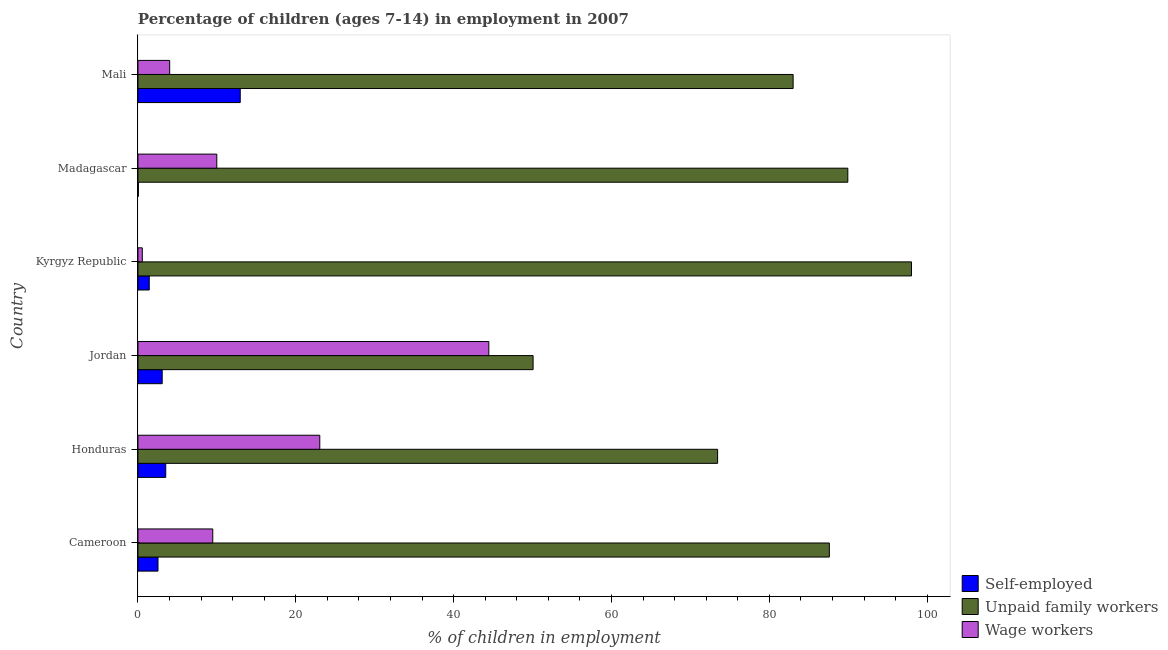How many different coloured bars are there?
Offer a terse response. 3. How many groups of bars are there?
Give a very brief answer. 6. Are the number of bars per tick equal to the number of legend labels?
Your answer should be compact. Yes. Are the number of bars on each tick of the Y-axis equal?
Keep it short and to the point. Yes. What is the label of the 4th group of bars from the top?
Provide a succinct answer. Jordan. What is the percentage of children employed as unpaid family workers in Cameroon?
Your answer should be very brief. 87.61. Across all countries, what is the maximum percentage of children employed as unpaid family workers?
Make the answer very short. 98.02. Across all countries, what is the minimum percentage of children employed as unpaid family workers?
Your answer should be compact. 50.07. In which country was the percentage of children employed as wage workers maximum?
Make the answer very short. Jordan. In which country was the percentage of self employed children minimum?
Give a very brief answer. Madagascar. What is the total percentage of self employed children in the graph?
Keep it short and to the point. 23.57. What is the difference between the percentage of children employed as wage workers in Jordan and that in Kyrgyz Republic?
Give a very brief answer. 43.91. What is the difference between the percentage of self employed children in Kyrgyz Republic and the percentage of children employed as unpaid family workers in Madagascar?
Make the answer very short. -88.52. What is the average percentage of self employed children per country?
Give a very brief answer. 3.93. What is the difference between the percentage of self employed children and percentage of children employed as wage workers in Mali?
Ensure brevity in your answer.  8.94. In how many countries, is the percentage of children employed as wage workers greater than 4 %?
Provide a succinct answer. 5. What is the ratio of the percentage of self employed children in Jordan to that in Madagascar?
Keep it short and to the point. 61.4. Is the percentage of children employed as wage workers in Jordan less than that in Kyrgyz Republic?
Make the answer very short. No. What is the difference between the highest and the second highest percentage of self employed children?
Offer a very short reply. 9.44. What is the difference between the highest and the lowest percentage of children employed as unpaid family workers?
Offer a terse response. 47.95. Is the sum of the percentage of self employed children in Kyrgyz Republic and Mali greater than the maximum percentage of children employed as unpaid family workers across all countries?
Make the answer very short. No. What does the 3rd bar from the top in Jordan represents?
Your answer should be compact. Self-employed. What does the 3rd bar from the bottom in Madagascar represents?
Give a very brief answer. Wage workers. Is it the case that in every country, the sum of the percentage of self employed children and percentage of children employed as unpaid family workers is greater than the percentage of children employed as wage workers?
Offer a very short reply. Yes. How many bars are there?
Make the answer very short. 18. Are all the bars in the graph horizontal?
Provide a short and direct response. Yes. How many countries are there in the graph?
Your response must be concise. 6. What is the difference between two consecutive major ticks on the X-axis?
Provide a succinct answer. 20. Are the values on the major ticks of X-axis written in scientific E-notation?
Give a very brief answer. No. Does the graph contain any zero values?
Your answer should be very brief. No. How many legend labels are there?
Keep it short and to the point. 3. How are the legend labels stacked?
Offer a very short reply. Vertical. What is the title of the graph?
Your answer should be very brief. Percentage of children (ages 7-14) in employment in 2007. Does "Maunufacturing" appear as one of the legend labels in the graph?
Give a very brief answer. No. What is the label or title of the X-axis?
Your answer should be compact. % of children in employment. What is the % of children in employment in Self-employed in Cameroon?
Your answer should be very brief. 2.54. What is the % of children in employment of Unpaid family workers in Cameroon?
Offer a very short reply. 87.61. What is the % of children in employment of Wage workers in Cameroon?
Provide a short and direct response. 9.48. What is the % of children in employment in Self-employed in Honduras?
Provide a short and direct response. 3.52. What is the % of children in employment of Unpaid family workers in Honduras?
Make the answer very short. 73.45. What is the % of children in employment of Wage workers in Honduras?
Provide a succinct answer. 23.04. What is the % of children in employment of Self-employed in Jordan?
Your answer should be compact. 3.07. What is the % of children in employment of Unpaid family workers in Jordan?
Provide a short and direct response. 50.07. What is the % of children in employment in Wage workers in Jordan?
Provide a succinct answer. 44.46. What is the % of children in employment in Self-employed in Kyrgyz Republic?
Your answer should be very brief. 1.43. What is the % of children in employment in Unpaid family workers in Kyrgyz Republic?
Ensure brevity in your answer.  98.02. What is the % of children in employment in Wage workers in Kyrgyz Republic?
Keep it short and to the point. 0.55. What is the % of children in employment of Unpaid family workers in Madagascar?
Make the answer very short. 89.95. What is the % of children in employment in Wage workers in Madagascar?
Offer a terse response. 9.99. What is the % of children in employment in Self-employed in Mali?
Give a very brief answer. 12.96. What is the % of children in employment in Unpaid family workers in Mali?
Provide a succinct answer. 83.02. What is the % of children in employment in Wage workers in Mali?
Ensure brevity in your answer.  4.02. Across all countries, what is the maximum % of children in employment of Self-employed?
Provide a short and direct response. 12.96. Across all countries, what is the maximum % of children in employment in Unpaid family workers?
Provide a short and direct response. 98.02. Across all countries, what is the maximum % of children in employment in Wage workers?
Provide a succinct answer. 44.46. Across all countries, what is the minimum % of children in employment in Unpaid family workers?
Offer a very short reply. 50.07. Across all countries, what is the minimum % of children in employment in Wage workers?
Give a very brief answer. 0.55. What is the total % of children in employment in Self-employed in the graph?
Your answer should be compact. 23.57. What is the total % of children in employment in Unpaid family workers in the graph?
Give a very brief answer. 482.12. What is the total % of children in employment in Wage workers in the graph?
Provide a short and direct response. 91.54. What is the difference between the % of children in employment in Self-employed in Cameroon and that in Honduras?
Your response must be concise. -0.98. What is the difference between the % of children in employment of Unpaid family workers in Cameroon and that in Honduras?
Give a very brief answer. 14.16. What is the difference between the % of children in employment of Wage workers in Cameroon and that in Honduras?
Your answer should be very brief. -13.56. What is the difference between the % of children in employment of Self-employed in Cameroon and that in Jordan?
Your response must be concise. -0.53. What is the difference between the % of children in employment of Unpaid family workers in Cameroon and that in Jordan?
Keep it short and to the point. 37.54. What is the difference between the % of children in employment in Wage workers in Cameroon and that in Jordan?
Offer a very short reply. -34.98. What is the difference between the % of children in employment of Self-employed in Cameroon and that in Kyrgyz Republic?
Make the answer very short. 1.11. What is the difference between the % of children in employment of Unpaid family workers in Cameroon and that in Kyrgyz Republic?
Provide a succinct answer. -10.41. What is the difference between the % of children in employment in Wage workers in Cameroon and that in Kyrgyz Republic?
Your response must be concise. 8.93. What is the difference between the % of children in employment in Self-employed in Cameroon and that in Madagascar?
Your response must be concise. 2.49. What is the difference between the % of children in employment in Unpaid family workers in Cameroon and that in Madagascar?
Offer a very short reply. -2.34. What is the difference between the % of children in employment of Wage workers in Cameroon and that in Madagascar?
Offer a terse response. -0.51. What is the difference between the % of children in employment of Self-employed in Cameroon and that in Mali?
Provide a short and direct response. -10.42. What is the difference between the % of children in employment in Unpaid family workers in Cameroon and that in Mali?
Keep it short and to the point. 4.59. What is the difference between the % of children in employment of Wage workers in Cameroon and that in Mali?
Offer a terse response. 5.46. What is the difference between the % of children in employment in Self-employed in Honduras and that in Jordan?
Ensure brevity in your answer.  0.45. What is the difference between the % of children in employment in Unpaid family workers in Honduras and that in Jordan?
Provide a short and direct response. 23.38. What is the difference between the % of children in employment of Wage workers in Honduras and that in Jordan?
Keep it short and to the point. -21.42. What is the difference between the % of children in employment in Self-employed in Honduras and that in Kyrgyz Republic?
Keep it short and to the point. 2.09. What is the difference between the % of children in employment of Unpaid family workers in Honduras and that in Kyrgyz Republic?
Your answer should be compact. -24.57. What is the difference between the % of children in employment in Wage workers in Honduras and that in Kyrgyz Republic?
Offer a terse response. 22.49. What is the difference between the % of children in employment of Self-employed in Honduras and that in Madagascar?
Your answer should be compact. 3.47. What is the difference between the % of children in employment of Unpaid family workers in Honduras and that in Madagascar?
Keep it short and to the point. -16.5. What is the difference between the % of children in employment in Wage workers in Honduras and that in Madagascar?
Offer a very short reply. 13.05. What is the difference between the % of children in employment of Self-employed in Honduras and that in Mali?
Provide a succinct answer. -9.44. What is the difference between the % of children in employment in Unpaid family workers in Honduras and that in Mali?
Make the answer very short. -9.57. What is the difference between the % of children in employment of Wage workers in Honduras and that in Mali?
Your answer should be very brief. 19.02. What is the difference between the % of children in employment in Self-employed in Jordan and that in Kyrgyz Republic?
Offer a terse response. 1.64. What is the difference between the % of children in employment of Unpaid family workers in Jordan and that in Kyrgyz Republic?
Give a very brief answer. -47.95. What is the difference between the % of children in employment of Wage workers in Jordan and that in Kyrgyz Republic?
Offer a very short reply. 43.91. What is the difference between the % of children in employment of Self-employed in Jordan and that in Madagascar?
Provide a short and direct response. 3.02. What is the difference between the % of children in employment of Unpaid family workers in Jordan and that in Madagascar?
Your response must be concise. -39.88. What is the difference between the % of children in employment of Wage workers in Jordan and that in Madagascar?
Offer a very short reply. 34.47. What is the difference between the % of children in employment in Self-employed in Jordan and that in Mali?
Keep it short and to the point. -9.89. What is the difference between the % of children in employment of Unpaid family workers in Jordan and that in Mali?
Make the answer very short. -32.95. What is the difference between the % of children in employment of Wage workers in Jordan and that in Mali?
Provide a short and direct response. 40.44. What is the difference between the % of children in employment in Self-employed in Kyrgyz Republic and that in Madagascar?
Offer a terse response. 1.38. What is the difference between the % of children in employment in Unpaid family workers in Kyrgyz Republic and that in Madagascar?
Your answer should be compact. 8.07. What is the difference between the % of children in employment in Wage workers in Kyrgyz Republic and that in Madagascar?
Ensure brevity in your answer.  -9.44. What is the difference between the % of children in employment in Self-employed in Kyrgyz Republic and that in Mali?
Your answer should be very brief. -11.53. What is the difference between the % of children in employment in Unpaid family workers in Kyrgyz Republic and that in Mali?
Your answer should be very brief. 15. What is the difference between the % of children in employment of Wage workers in Kyrgyz Republic and that in Mali?
Your response must be concise. -3.47. What is the difference between the % of children in employment in Self-employed in Madagascar and that in Mali?
Give a very brief answer. -12.91. What is the difference between the % of children in employment of Unpaid family workers in Madagascar and that in Mali?
Ensure brevity in your answer.  6.93. What is the difference between the % of children in employment in Wage workers in Madagascar and that in Mali?
Provide a succinct answer. 5.97. What is the difference between the % of children in employment of Self-employed in Cameroon and the % of children in employment of Unpaid family workers in Honduras?
Offer a terse response. -70.91. What is the difference between the % of children in employment in Self-employed in Cameroon and the % of children in employment in Wage workers in Honduras?
Your answer should be compact. -20.5. What is the difference between the % of children in employment in Unpaid family workers in Cameroon and the % of children in employment in Wage workers in Honduras?
Offer a terse response. 64.57. What is the difference between the % of children in employment in Self-employed in Cameroon and the % of children in employment in Unpaid family workers in Jordan?
Make the answer very short. -47.53. What is the difference between the % of children in employment in Self-employed in Cameroon and the % of children in employment in Wage workers in Jordan?
Your response must be concise. -41.92. What is the difference between the % of children in employment of Unpaid family workers in Cameroon and the % of children in employment of Wage workers in Jordan?
Offer a very short reply. 43.15. What is the difference between the % of children in employment of Self-employed in Cameroon and the % of children in employment of Unpaid family workers in Kyrgyz Republic?
Offer a very short reply. -95.48. What is the difference between the % of children in employment in Self-employed in Cameroon and the % of children in employment in Wage workers in Kyrgyz Republic?
Your answer should be compact. 1.99. What is the difference between the % of children in employment of Unpaid family workers in Cameroon and the % of children in employment of Wage workers in Kyrgyz Republic?
Give a very brief answer. 87.06. What is the difference between the % of children in employment in Self-employed in Cameroon and the % of children in employment in Unpaid family workers in Madagascar?
Offer a terse response. -87.41. What is the difference between the % of children in employment of Self-employed in Cameroon and the % of children in employment of Wage workers in Madagascar?
Offer a very short reply. -7.45. What is the difference between the % of children in employment of Unpaid family workers in Cameroon and the % of children in employment of Wage workers in Madagascar?
Make the answer very short. 77.62. What is the difference between the % of children in employment of Self-employed in Cameroon and the % of children in employment of Unpaid family workers in Mali?
Ensure brevity in your answer.  -80.48. What is the difference between the % of children in employment in Self-employed in Cameroon and the % of children in employment in Wage workers in Mali?
Offer a very short reply. -1.48. What is the difference between the % of children in employment of Unpaid family workers in Cameroon and the % of children in employment of Wage workers in Mali?
Offer a very short reply. 83.59. What is the difference between the % of children in employment of Self-employed in Honduras and the % of children in employment of Unpaid family workers in Jordan?
Make the answer very short. -46.55. What is the difference between the % of children in employment of Self-employed in Honduras and the % of children in employment of Wage workers in Jordan?
Ensure brevity in your answer.  -40.94. What is the difference between the % of children in employment in Unpaid family workers in Honduras and the % of children in employment in Wage workers in Jordan?
Offer a very short reply. 28.99. What is the difference between the % of children in employment of Self-employed in Honduras and the % of children in employment of Unpaid family workers in Kyrgyz Republic?
Ensure brevity in your answer.  -94.5. What is the difference between the % of children in employment of Self-employed in Honduras and the % of children in employment of Wage workers in Kyrgyz Republic?
Your answer should be very brief. 2.97. What is the difference between the % of children in employment of Unpaid family workers in Honduras and the % of children in employment of Wage workers in Kyrgyz Republic?
Give a very brief answer. 72.9. What is the difference between the % of children in employment in Self-employed in Honduras and the % of children in employment in Unpaid family workers in Madagascar?
Give a very brief answer. -86.43. What is the difference between the % of children in employment in Self-employed in Honduras and the % of children in employment in Wage workers in Madagascar?
Provide a succinct answer. -6.47. What is the difference between the % of children in employment in Unpaid family workers in Honduras and the % of children in employment in Wage workers in Madagascar?
Keep it short and to the point. 63.46. What is the difference between the % of children in employment in Self-employed in Honduras and the % of children in employment in Unpaid family workers in Mali?
Keep it short and to the point. -79.5. What is the difference between the % of children in employment of Unpaid family workers in Honduras and the % of children in employment of Wage workers in Mali?
Provide a short and direct response. 69.43. What is the difference between the % of children in employment of Self-employed in Jordan and the % of children in employment of Unpaid family workers in Kyrgyz Republic?
Ensure brevity in your answer.  -94.95. What is the difference between the % of children in employment of Self-employed in Jordan and the % of children in employment of Wage workers in Kyrgyz Republic?
Offer a terse response. 2.52. What is the difference between the % of children in employment in Unpaid family workers in Jordan and the % of children in employment in Wage workers in Kyrgyz Republic?
Ensure brevity in your answer.  49.52. What is the difference between the % of children in employment of Self-employed in Jordan and the % of children in employment of Unpaid family workers in Madagascar?
Provide a succinct answer. -86.88. What is the difference between the % of children in employment in Self-employed in Jordan and the % of children in employment in Wage workers in Madagascar?
Make the answer very short. -6.92. What is the difference between the % of children in employment in Unpaid family workers in Jordan and the % of children in employment in Wage workers in Madagascar?
Provide a short and direct response. 40.08. What is the difference between the % of children in employment in Self-employed in Jordan and the % of children in employment in Unpaid family workers in Mali?
Ensure brevity in your answer.  -79.95. What is the difference between the % of children in employment of Self-employed in Jordan and the % of children in employment of Wage workers in Mali?
Make the answer very short. -0.95. What is the difference between the % of children in employment of Unpaid family workers in Jordan and the % of children in employment of Wage workers in Mali?
Your response must be concise. 46.05. What is the difference between the % of children in employment in Self-employed in Kyrgyz Republic and the % of children in employment in Unpaid family workers in Madagascar?
Your response must be concise. -88.52. What is the difference between the % of children in employment in Self-employed in Kyrgyz Republic and the % of children in employment in Wage workers in Madagascar?
Provide a short and direct response. -8.56. What is the difference between the % of children in employment of Unpaid family workers in Kyrgyz Republic and the % of children in employment of Wage workers in Madagascar?
Your answer should be compact. 88.03. What is the difference between the % of children in employment of Self-employed in Kyrgyz Republic and the % of children in employment of Unpaid family workers in Mali?
Your answer should be very brief. -81.59. What is the difference between the % of children in employment of Self-employed in Kyrgyz Republic and the % of children in employment of Wage workers in Mali?
Your response must be concise. -2.59. What is the difference between the % of children in employment of Unpaid family workers in Kyrgyz Republic and the % of children in employment of Wage workers in Mali?
Make the answer very short. 94. What is the difference between the % of children in employment of Self-employed in Madagascar and the % of children in employment of Unpaid family workers in Mali?
Offer a terse response. -82.97. What is the difference between the % of children in employment in Self-employed in Madagascar and the % of children in employment in Wage workers in Mali?
Provide a short and direct response. -3.97. What is the difference between the % of children in employment in Unpaid family workers in Madagascar and the % of children in employment in Wage workers in Mali?
Your answer should be very brief. 85.93. What is the average % of children in employment of Self-employed per country?
Provide a succinct answer. 3.93. What is the average % of children in employment of Unpaid family workers per country?
Keep it short and to the point. 80.35. What is the average % of children in employment in Wage workers per country?
Offer a terse response. 15.26. What is the difference between the % of children in employment of Self-employed and % of children in employment of Unpaid family workers in Cameroon?
Keep it short and to the point. -85.07. What is the difference between the % of children in employment of Self-employed and % of children in employment of Wage workers in Cameroon?
Provide a succinct answer. -6.94. What is the difference between the % of children in employment of Unpaid family workers and % of children in employment of Wage workers in Cameroon?
Provide a succinct answer. 78.13. What is the difference between the % of children in employment in Self-employed and % of children in employment in Unpaid family workers in Honduras?
Make the answer very short. -69.93. What is the difference between the % of children in employment in Self-employed and % of children in employment in Wage workers in Honduras?
Make the answer very short. -19.52. What is the difference between the % of children in employment of Unpaid family workers and % of children in employment of Wage workers in Honduras?
Make the answer very short. 50.41. What is the difference between the % of children in employment in Self-employed and % of children in employment in Unpaid family workers in Jordan?
Your answer should be very brief. -47. What is the difference between the % of children in employment in Self-employed and % of children in employment in Wage workers in Jordan?
Make the answer very short. -41.39. What is the difference between the % of children in employment of Unpaid family workers and % of children in employment of Wage workers in Jordan?
Provide a succinct answer. 5.61. What is the difference between the % of children in employment in Self-employed and % of children in employment in Unpaid family workers in Kyrgyz Republic?
Provide a succinct answer. -96.59. What is the difference between the % of children in employment of Unpaid family workers and % of children in employment of Wage workers in Kyrgyz Republic?
Your answer should be compact. 97.47. What is the difference between the % of children in employment of Self-employed and % of children in employment of Unpaid family workers in Madagascar?
Ensure brevity in your answer.  -89.9. What is the difference between the % of children in employment in Self-employed and % of children in employment in Wage workers in Madagascar?
Provide a succinct answer. -9.94. What is the difference between the % of children in employment in Unpaid family workers and % of children in employment in Wage workers in Madagascar?
Offer a terse response. 79.96. What is the difference between the % of children in employment in Self-employed and % of children in employment in Unpaid family workers in Mali?
Give a very brief answer. -70.06. What is the difference between the % of children in employment in Self-employed and % of children in employment in Wage workers in Mali?
Provide a short and direct response. 8.94. What is the difference between the % of children in employment in Unpaid family workers and % of children in employment in Wage workers in Mali?
Your answer should be very brief. 79. What is the ratio of the % of children in employment of Self-employed in Cameroon to that in Honduras?
Make the answer very short. 0.72. What is the ratio of the % of children in employment of Unpaid family workers in Cameroon to that in Honduras?
Offer a terse response. 1.19. What is the ratio of the % of children in employment in Wage workers in Cameroon to that in Honduras?
Keep it short and to the point. 0.41. What is the ratio of the % of children in employment in Self-employed in Cameroon to that in Jordan?
Ensure brevity in your answer.  0.83. What is the ratio of the % of children in employment in Unpaid family workers in Cameroon to that in Jordan?
Make the answer very short. 1.75. What is the ratio of the % of children in employment in Wage workers in Cameroon to that in Jordan?
Your answer should be compact. 0.21. What is the ratio of the % of children in employment in Self-employed in Cameroon to that in Kyrgyz Republic?
Offer a very short reply. 1.78. What is the ratio of the % of children in employment in Unpaid family workers in Cameroon to that in Kyrgyz Republic?
Keep it short and to the point. 0.89. What is the ratio of the % of children in employment of Wage workers in Cameroon to that in Kyrgyz Republic?
Offer a very short reply. 17.24. What is the ratio of the % of children in employment of Self-employed in Cameroon to that in Madagascar?
Give a very brief answer. 50.8. What is the ratio of the % of children in employment in Unpaid family workers in Cameroon to that in Madagascar?
Provide a short and direct response. 0.97. What is the ratio of the % of children in employment in Wage workers in Cameroon to that in Madagascar?
Your answer should be very brief. 0.95. What is the ratio of the % of children in employment of Self-employed in Cameroon to that in Mali?
Provide a succinct answer. 0.2. What is the ratio of the % of children in employment in Unpaid family workers in Cameroon to that in Mali?
Keep it short and to the point. 1.06. What is the ratio of the % of children in employment of Wage workers in Cameroon to that in Mali?
Keep it short and to the point. 2.36. What is the ratio of the % of children in employment of Self-employed in Honduras to that in Jordan?
Ensure brevity in your answer.  1.15. What is the ratio of the % of children in employment of Unpaid family workers in Honduras to that in Jordan?
Offer a very short reply. 1.47. What is the ratio of the % of children in employment of Wage workers in Honduras to that in Jordan?
Give a very brief answer. 0.52. What is the ratio of the % of children in employment of Self-employed in Honduras to that in Kyrgyz Republic?
Keep it short and to the point. 2.46. What is the ratio of the % of children in employment in Unpaid family workers in Honduras to that in Kyrgyz Republic?
Your answer should be compact. 0.75. What is the ratio of the % of children in employment of Wage workers in Honduras to that in Kyrgyz Republic?
Give a very brief answer. 41.89. What is the ratio of the % of children in employment of Self-employed in Honduras to that in Madagascar?
Your answer should be very brief. 70.4. What is the ratio of the % of children in employment in Unpaid family workers in Honduras to that in Madagascar?
Keep it short and to the point. 0.82. What is the ratio of the % of children in employment in Wage workers in Honduras to that in Madagascar?
Provide a succinct answer. 2.31. What is the ratio of the % of children in employment in Self-employed in Honduras to that in Mali?
Provide a succinct answer. 0.27. What is the ratio of the % of children in employment in Unpaid family workers in Honduras to that in Mali?
Provide a short and direct response. 0.88. What is the ratio of the % of children in employment of Wage workers in Honduras to that in Mali?
Offer a very short reply. 5.73. What is the ratio of the % of children in employment of Self-employed in Jordan to that in Kyrgyz Republic?
Offer a very short reply. 2.15. What is the ratio of the % of children in employment of Unpaid family workers in Jordan to that in Kyrgyz Republic?
Give a very brief answer. 0.51. What is the ratio of the % of children in employment of Wage workers in Jordan to that in Kyrgyz Republic?
Make the answer very short. 80.84. What is the ratio of the % of children in employment of Self-employed in Jordan to that in Madagascar?
Provide a short and direct response. 61.4. What is the ratio of the % of children in employment in Unpaid family workers in Jordan to that in Madagascar?
Provide a short and direct response. 0.56. What is the ratio of the % of children in employment of Wage workers in Jordan to that in Madagascar?
Offer a very short reply. 4.45. What is the ratio of the % of children in employment in Self-employed in Jordan to that in Mali?
Provide a succinct answer. 0.24. What is the ratio of the % of children in employment of Unpaid family workers in Jordan to that in Mali?
Keep it short and to the point. 0.6. What is the ratio of the % of children in employment of Wage workers in Jordan to that in Mali?
Provide a succinct answer. 11.06. What is the ratio of the % of children in employment of Self-employed in Kyrgyz Republic to that in Madagascar?
Your answer should be very brief. 28.6. What is the ratio of the % of children in employment of Unpaid family workers in Kyrgyz Republic to that in Madagascar?
Provide a succinct answer. 1.09. What is the ratio of the % of children in employment in Wage workers in Kyrgyz Republic to that in Madagascar?
Give a very brief answer. 0.06. What is the ratio of the % of children in employment in Self-employed in Kyrgyz Republic to that in Mali?
Make the answer very short. 0.11. What is the ratio of the % of children in employment of Unpaid family workers in Kyrgyz Republic to that in Mali?
Your response must be concise. 1.18. What is the ratio of the % of children in employment of Wage workers in Kyrgyz Republic to that in Mali?
Give a very brief answer. 0.14. What is the ratio of the % of children in employment of Self-employed in Madagascar to that in Mali?
Ensure brevity in your answer.  0. What is the ratio of the % of children in employment of Unpaid family workers in Madagascar to that in Mali?
Give a very brief answer. 1.08. What is the ratio of the % of children in employment of Wage workers in Madagascar to that in Mali?
Give a very brief answer. 2.49. What is the difference between the highest and the second highest % of children in employment in Self-employed?
Offer a terse response. 9.44. What is the difference between the highest and the second highest % of children in employment of Unpaid family workers?
Offer a terse response. 8.07. What is the difference between the highest and the second highest % of children in employment in Wage workers?
Your answer should be very brief. 21.42. What is the difference between the highest and the lowest % of children in employment in Self-employed?
Ensure brevity in your answer.  12.91. What is the difference between the highest and the lowest % of children in employment in Unpaid family workers?
Make the answer very short. 47.95. What is the difference between the highest and the lowest % of children in employment of Wage workers?
Keep it short and to the point. 43.91. 